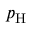Convert formula to latex. <formula><loc_0><loc_0><loc_500><loc_500>p _ { H }</formula> 